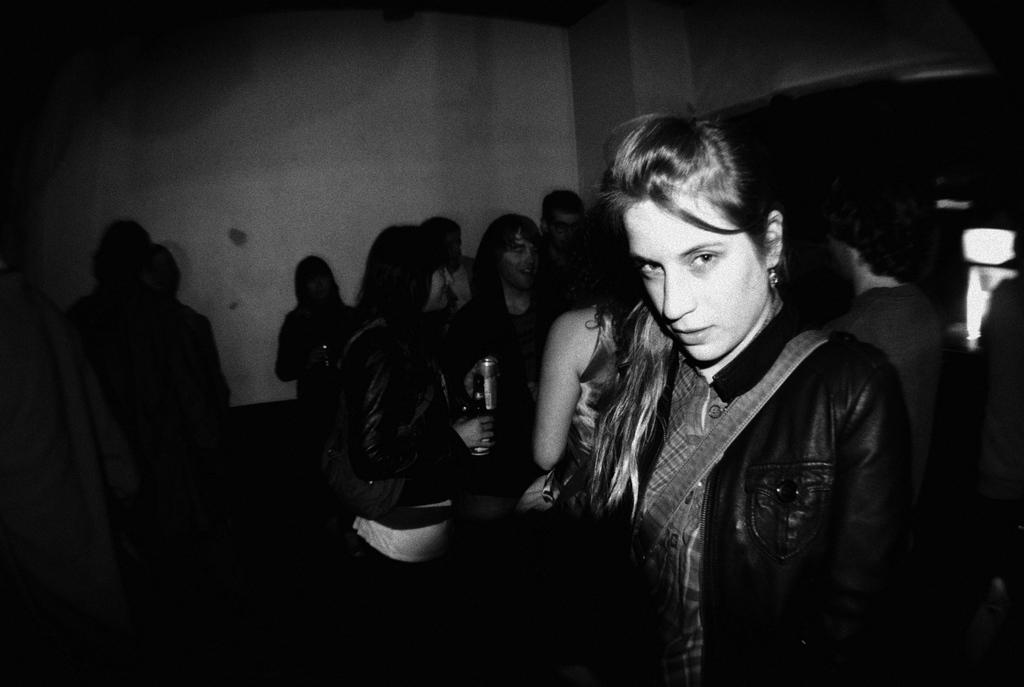What is the color scheme of the image? The image is black and white. What can be seen on the ground in the image? There are many persons on the ground in the image. What is visible in the background of the image? There is a wall in the background of the image. What type of locket is being polished by one of the persons in the image? There is no locket or polishing activity visible in the image. What flavor of soda is being consumed by the persons in the image? There is no soda present in the image. 